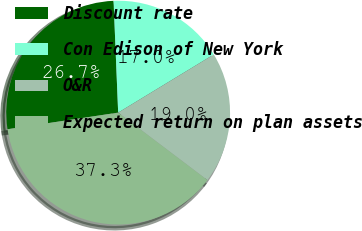Convert chart. <chart><loc_0><loc_0><loc_500><loc_500><pie_chart><fcel>Discount rate<fcel>Con Edison of New York<fcel>O&R<fcel>Expected return on plan assets<nl><fcel>26.72%<fcel>16.96%<fcel>19.0%<fcel>37.32%<nl></chart> 